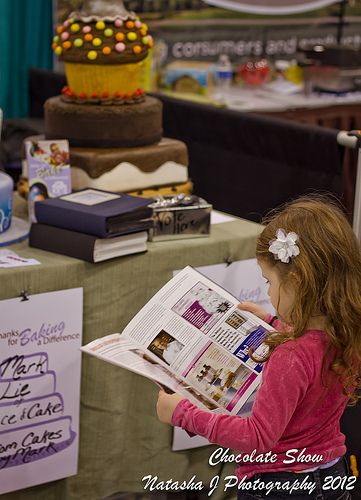What type of event might this image depict based on the surrounding elements? This image likely depicts a dessert or culinary exhibition, suggested by displays of elaborately decorated cakes and informational banners about cake decorating. 